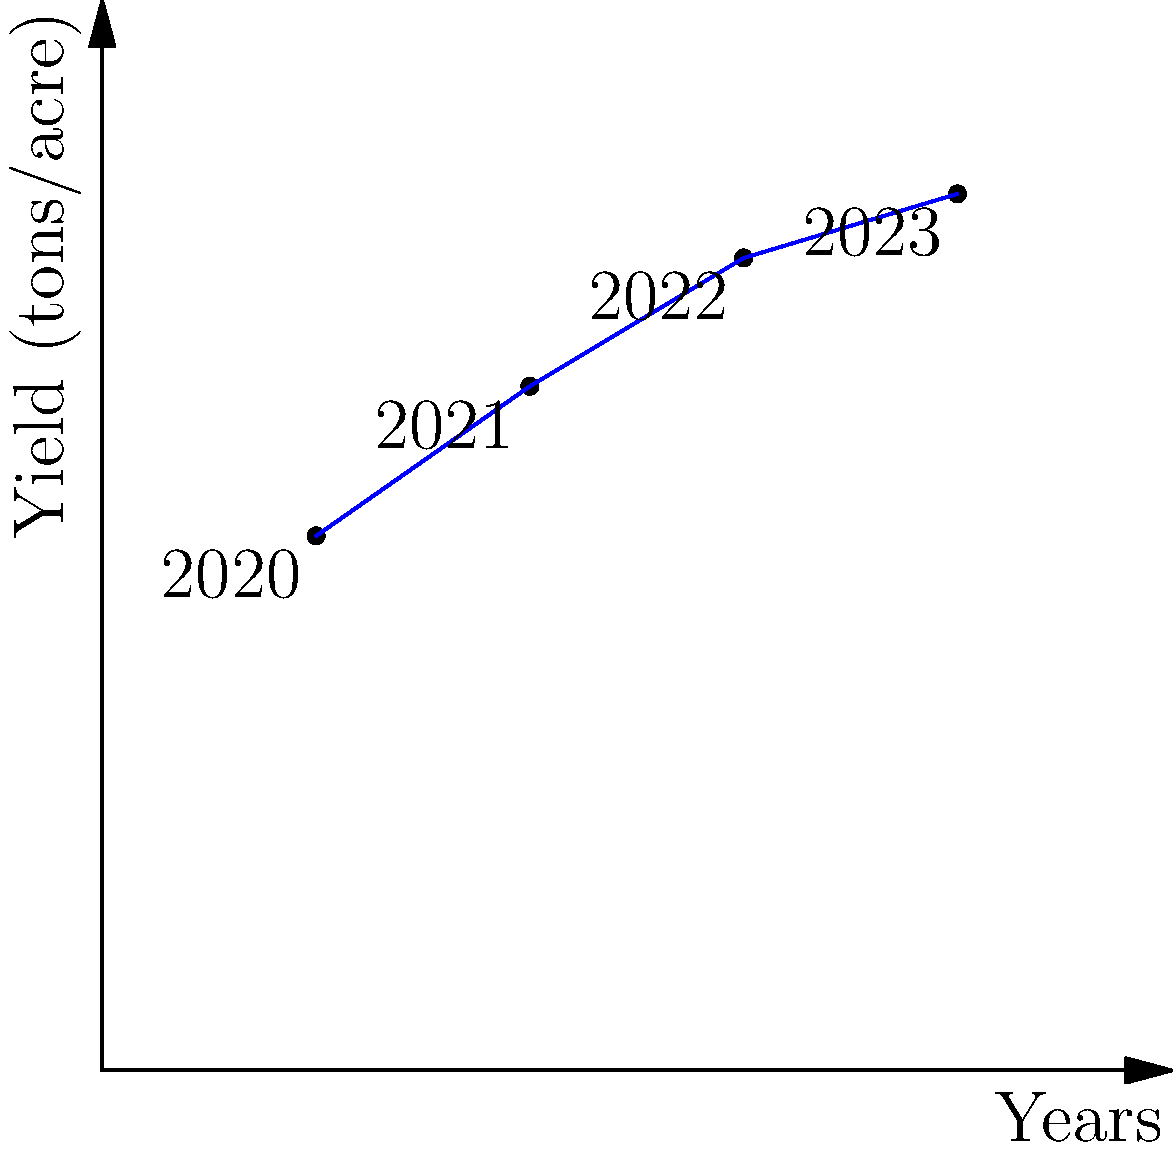Based on the graph showing your crop yield data from 2020 to 2023, calculate the average annual increase in yield (tons/acre) over this period. Round your answer to two decimal places. To calculate the average annual increase in yield:

1. Calculate total increase:
   Final yield (2023) - Initial yield (2020) = $4.1 - 2.5 = 1.6$ tons/acre

2. Determine the number of years:
   2023 - 2020 = 3 years

3. Calculate average annual increase:
   $\frac{\text{Total increase}}{\text{Number of years}} = \frac{1.6}{3} = 0.5333...$

4. Round to two decimal places:
   $0.53$ tons/acre/year
Answer: $0.53$ tons/acre/year 